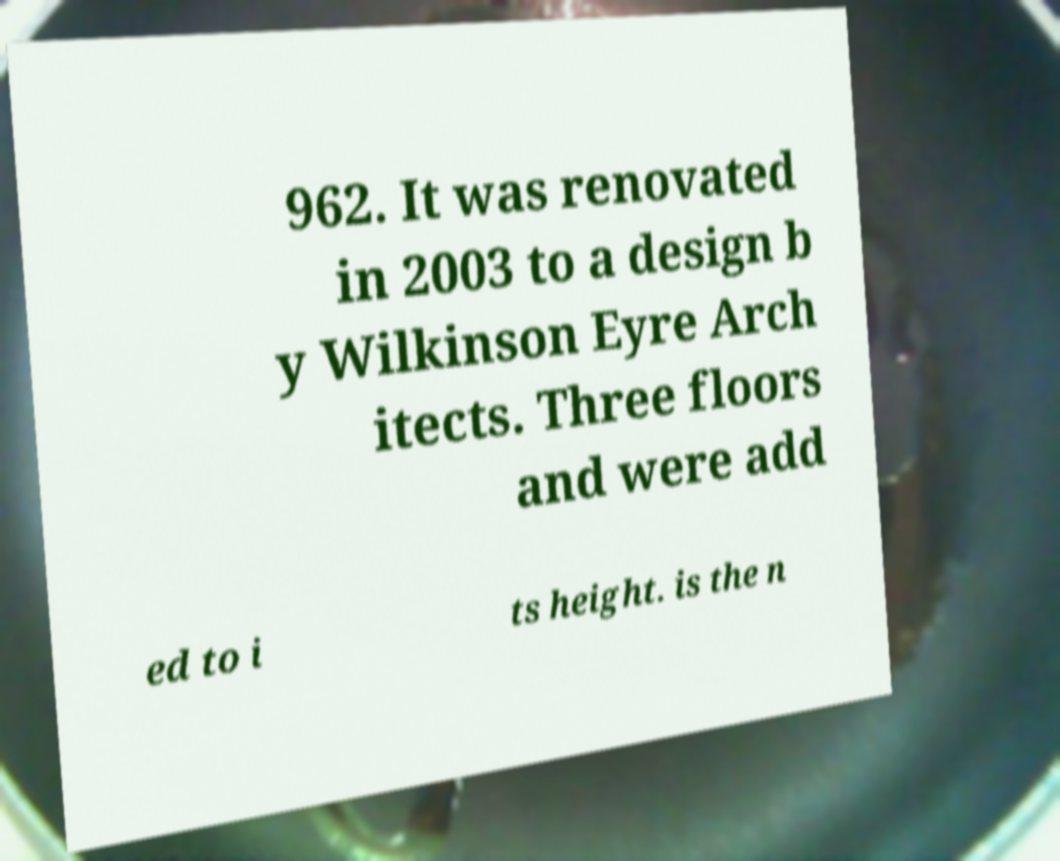Please identify and transcribe the text found in this image. 962. It was renovated in 2003 to a design b y Wilkinson Eyre Arch itects. Three floors and were add ed to i ts height. is the n 